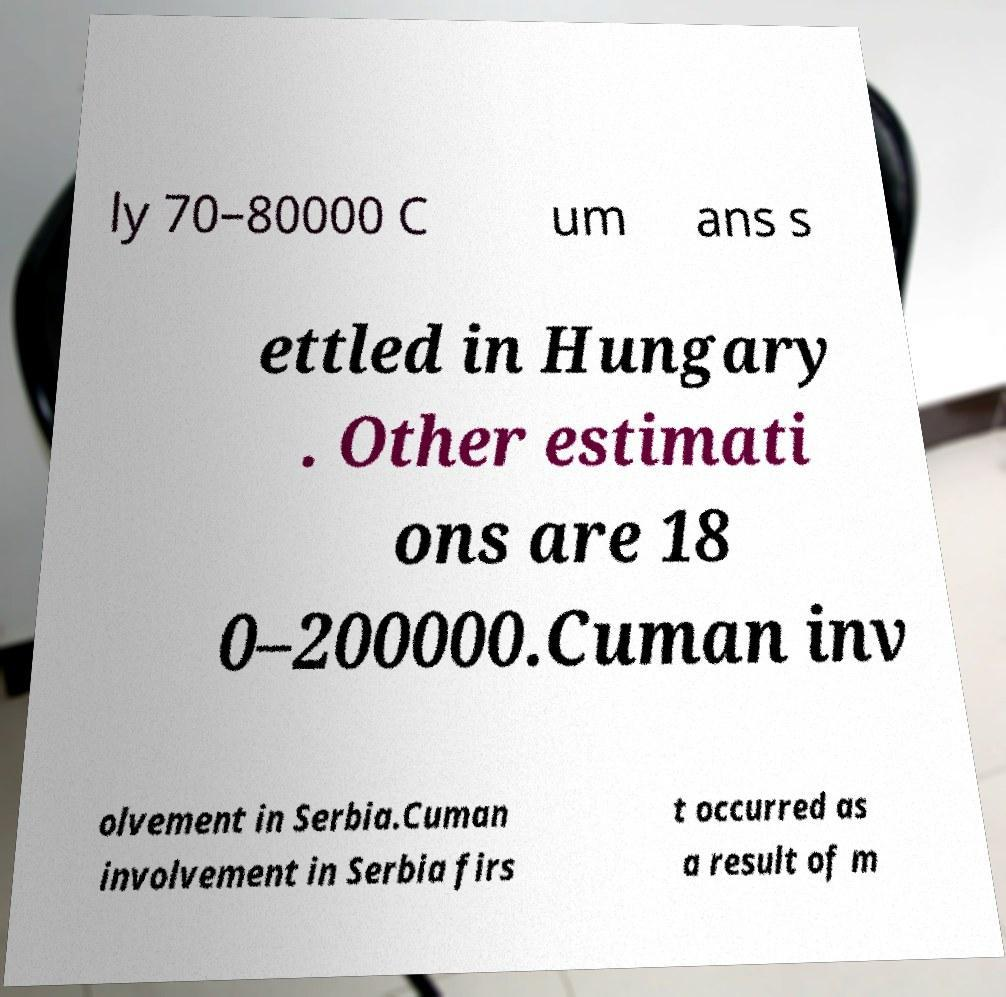Could you assist in decoding the text presented in this image and type it out clearly? ly 70–80000 C um ans s ettled in Hungary . Other estimati ons are 18 0–200000.Cuman inv olvement in Serbia.Cuman involvement in Serbia firs t occurred as a result of m 